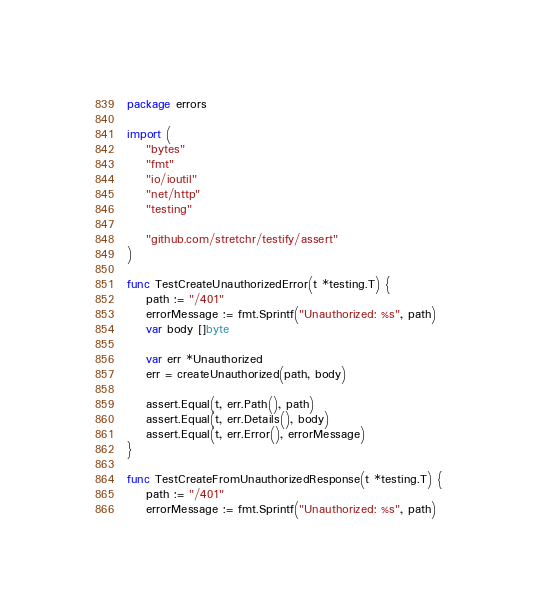Convert code to text. <code><loc_0><loc_0><loc_500><loc_500><_Go_>package errors

import (
	"bytes"
	"fmt"
	"io/ioutil"
	"net/http"
	"testing"

	"github.com/stretchr/testify/assert"
)

func TestCreateUnauthorizedError(t *testing.T) {
	path := "/401"
	errorMessage := fmt.Sprintf("Unauthorized: %s", path)
	var body []byte

	var err *Unauthorized
	err = createUnauthorized(path, body)

	assert.Equal(t, err.Path(), path)
	assert.Equal(t, err.Details(), body)
	assert.Equal(t, err.Error(), errorMessage)
}

func TestCreateFromUnauthorizedResponse(t *testing.T) {
	path := "/401"
	errorMessage := fmt.Sprintf("Unauthorized: %s", path)
</code> 